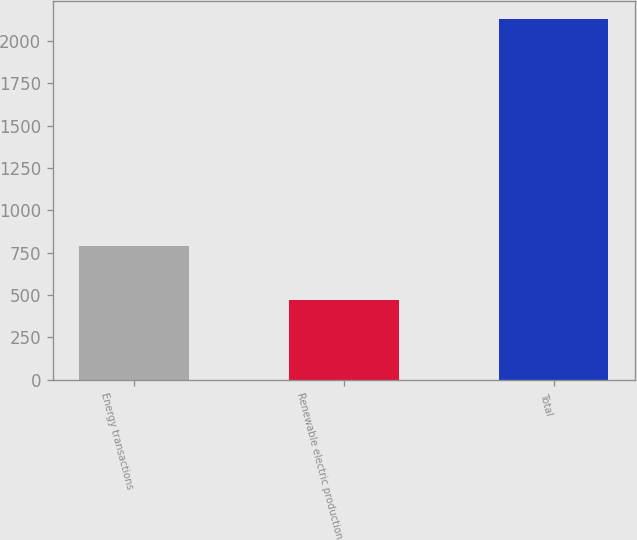<chart> <loc_0><loc_0><loc_500><loc_500><bar_chart><fcel>Energy transactions<fcel>Renewable electric production<fcel>Total<nl><fcel>792<fcel>471<fcel>2129<nl></chart> 